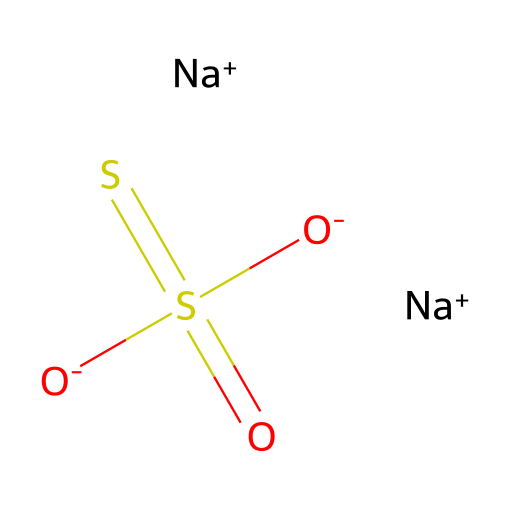how many sodium ions are present in the structure? The SMILES representation shows [Na+] twice, indicating there are two sodium ions in total.
Answer: two what is the oxidation state of sulfur in this chemical? Analyzing the structure, the sulfur attached to the sulfonyl groups (with a -2 charge overall) suggests it has a +6 oxidation state.
Answer: +6 what type of functional groups are present in this compound? The presence of the sulfonyl groups (S=O) in the structure indicates the presence of sulfonate functional groups.
Answer: sulfonate what is the total number of oxygen atoms in this chemical? In the structure, there are four total oxygen atoms represented within the sulfonyl groups and the sulfinate structure.
Answer: four how does the presence of sodium ions affect the solubility of this chemical? The presence of sodium ions typically increases the solubility of ionic compounds in polar solvents due to charge stabilization.
Answer: increases what is the significance of sulfonyl groups in photoresist applications? Sulfonyl groups can enhance the chemical stability and resolution of photoresists, serving crucial roles in their effectiveness in development processes.
Answer: enhance stability 